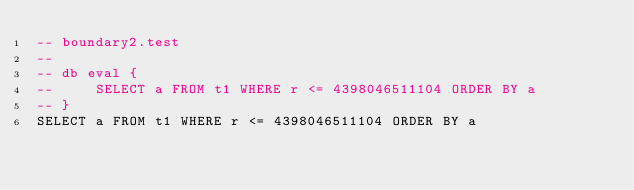Convert code to text. <code><loc_0><loc_0><loc_500><loc_500><_SQL_>-- boundary2.test
-- 
-- db eval {
--     SELECT a FROM t1 WHERE r <= 4398046511104 ORDER BY a
-- }
SELECT a FROM t1 WHERE r <= 4398046511104 ORDER BY a</code> 